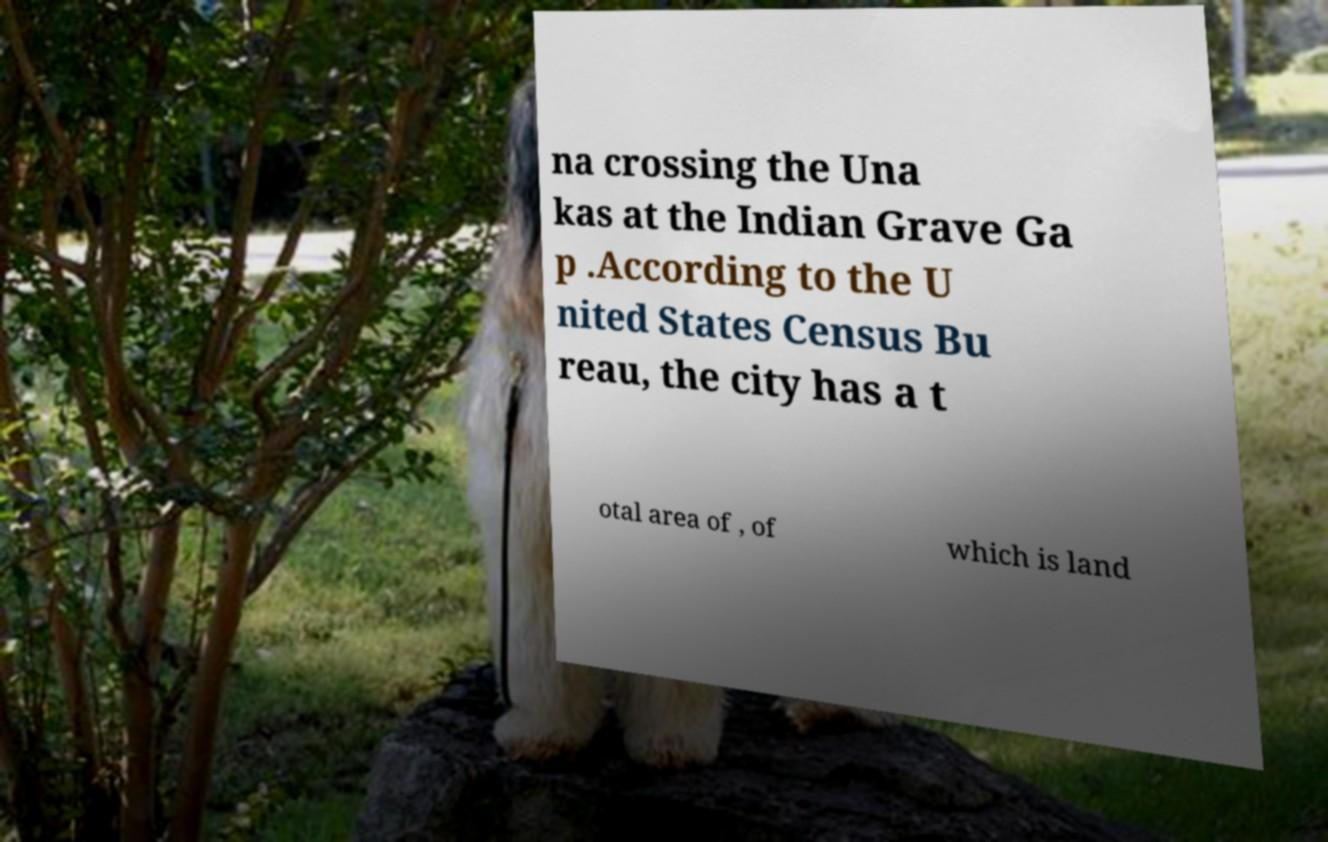Please identify and transcribe the text found in this image. na crossing the Una kas at the Indian Grave Ga p .According to the U nited States Census Bu reau, the city has a t otal area of , of which is land 